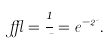<formula> <loc_0><loc_0><loc_500><loc_500>\epsilon = \frac { 1 } { \mu } = e ^ { - 2 \psi } .</formula> 